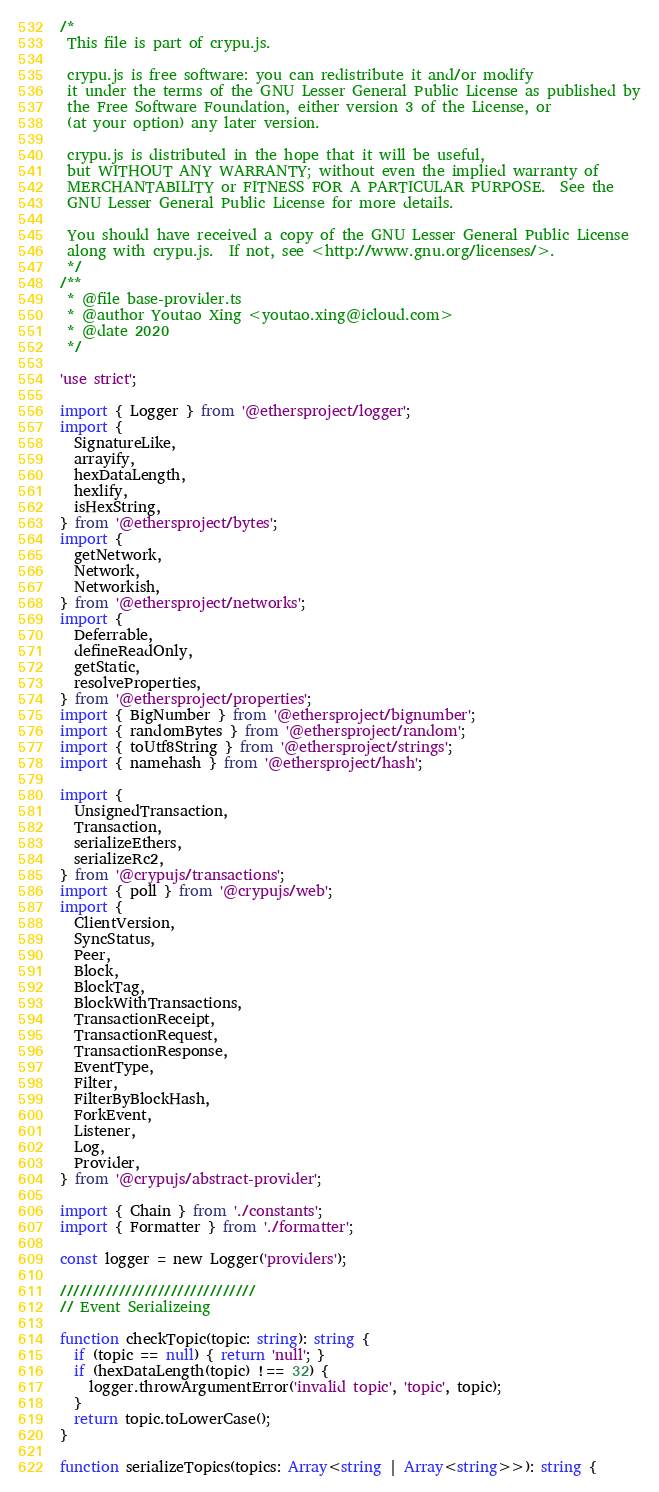Convert code to text. <code><loc_0><loc_0><loc_500><loc_500><_TypeScript_>/*
 This file is part of crypu.js.

 crypu.js is free software: you can redistribute it and/or modify
 it under the terms of the GNU Lesser General Public License as published by
 the Free Software Foundation, either version 3 of the License, or
 (at your option) any later version.

 crypu.js is distributed in the hope that it will be useful,
 but WITHOUT ANY WARRANTY; without even the implied warranty of
 MERCHANTABILITY or FITNESS FOR A PARTICULAR PURPOSE.  See the
 GNU Lesser General Public License for more details.

 You should have received a copy of the GNU Lesser General Public License
 along with crypu.js.  If not, see <http://www.gnu.org/licenses/>.
 */
/**
 * @file base-provider.ts
 * @author Youtao Xing <youtao.xing@icloud.com>
 * @date 2020
 */

'use strict';

import { Logger } from '@ethersproject/logger';
import {
  SignatureLike,
  arrayify,
  hexDataLength,
  hexlify,
  isHexString,
} from '@ethersproject/bytes';
import {
  getNetwork,
  Network,
  Networkish,
} from '@ethersproject/networks';
import {
  Deferrable,
  defineReadOnly,
  getStatic,
  resolveProperties,
} from '@ethersproject/properties';
import { BigNumber } from '@ethersproject/bignumber';
import { randomBytes } from '@ethersproject/random';
import { toUtf8String } from '@ethersproject/strings';
import { namehash } from '@ethersproject/hash';

import {
  UnsignedTransaction,
  Transaction,
  serializeEthers,
  serializeRc2,
} from '@crypujs/transactions';
import { poll } from '@crypujs/web';
import {
  ClientVersion,
  SyncStatus,
  Peer,
  Block,
  BlockTag,
  BlockWithTransactions,
  TransactionReceipt,
  TransactionRequest,
  TransactionResponse,
  EventType,
  Filter,
  FilterByBlockHash,
  ForkEvent,
  Listener,
  Log,
  Provider,
} from '@crypujs/abstract-provider';

import { Chain } from './constants';
import { Formatter } from './formatter';

const logger = new Logger('providers');

//////////////////////////////
// Event Serializeing

function checkTopic(topic: string): string {
  if (topic == null) { return 'null'; }
  if (hexDataLength(topic) !== 32) {
    logger.throwArgumentError('invalid topic', 'topic', topic);
  }
  return topic.toLowerCase();
}

function serializeTopics(topics: Array<string | Array<string>>): string {</code> 